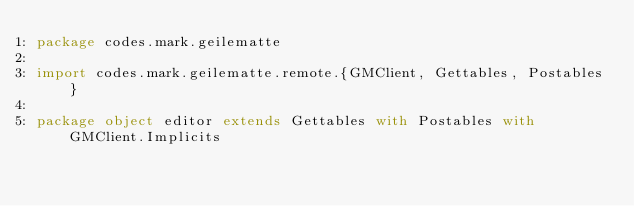Convert code to text. <code><loc_0><loc_0><loc_500><loc_500><_Scala_>package codes.mark.geilematte

import codes.mark.geilematte.remote.{GMClient, Gettables, Postables}

package object editor extends Gettables with Postables with GMClient.Implicits
</code> 